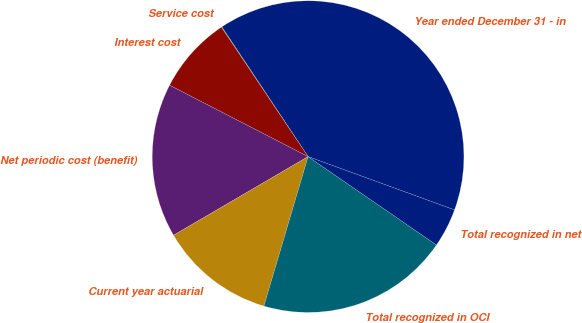Convert chart to OTSL. <chart><loc_0><loc_0><loc_500><loc_500><pie_chart><fcel>Year ended December 31 - in<fcel>Service cost<fcel>Interest cost<fcel>Net periodic cost (benefit)<fcel>Current year actuarial<fcel>Total recognized in OCI<fcel>Total recognized in net<nl><fcel>39.89%<fcel>0.06%<fcel>8.03%<fcel>15.99%<fcel>12.01%<fcel>19.98%<fcel>4.04%<nl></chart> 